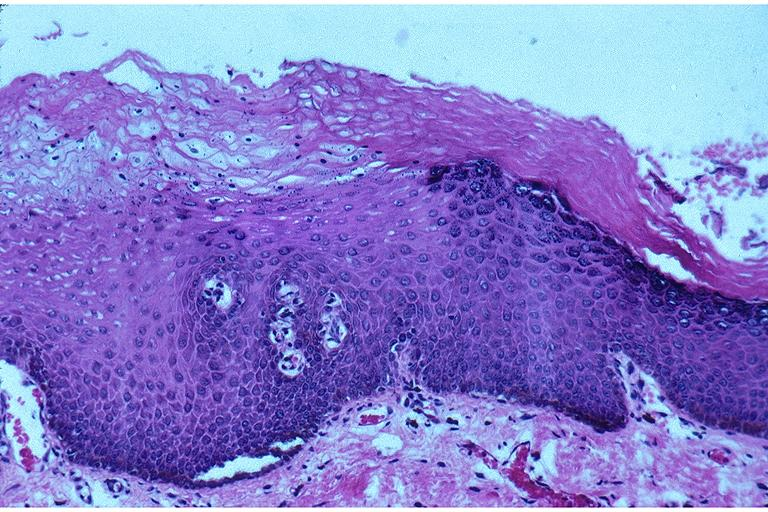s oral present?
Answer the question using a single word or phrase. Yes 